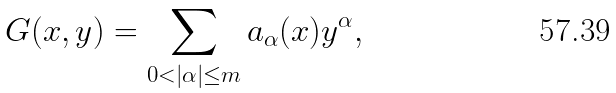<formula> <loc_0><loc_0><loc_500><loc_500>G ( x , y ) = \sum _ { 0 < | \alpha | \leq m } a _ { \alpha } ( x ) y ^ { \alpha } ,</formula> 